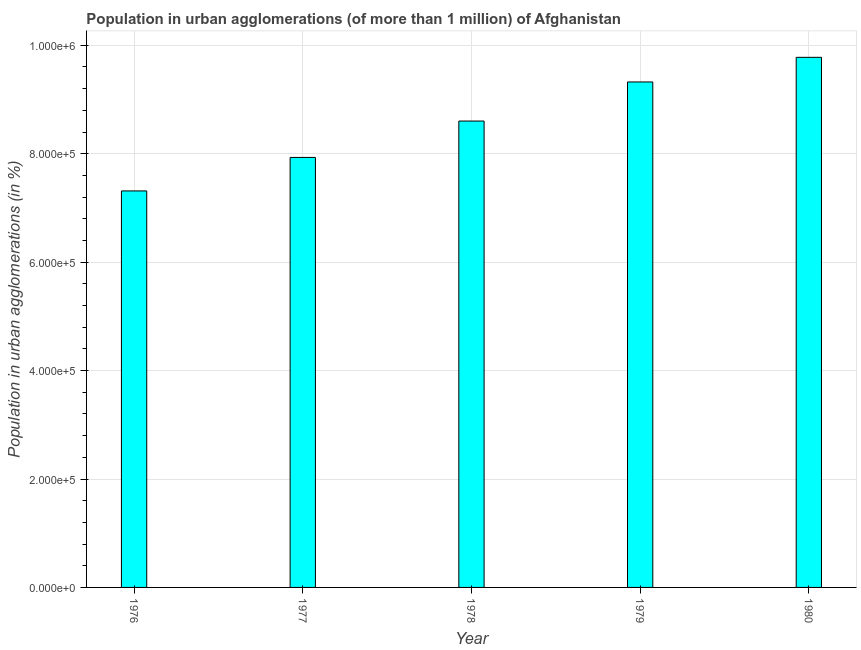Does the graph contain grids?
Give a very brief answer. Yes. What is the title of the graph?
Give a very brief answer. Population in urban agglomerations (of more than 1 million) of Afghanistan. What is the label or title of the X-axis?
Your response must be concise. Year. What is the label or title of the Y-axis?
Provide a succinct answer. Population in urban agglomerations (in %). What is the population in urban agglomerations in 1977?
Make the answer very short. 7.93e+05. Across all years, what is the maximum population in urban agglomerations?
Provide a short and direct response. 9.78e+05. Across all years, what is the minimum population in urban agglomerations?
Make the answer very short. 7.31e+05. In which year was the population in urban agglomerations maximum?
Give a very brief answer. 1980. In which year was the population in urban agglomerations minimum?
Provide a succinct answer. 1976. What is the sum of the population in urban agglomerations?
Provide a succinct answer. 4.30e+06. What is the difference between the population in urban agglomerations in 1976 and 1980?
Provide a succinct answer. -2.46e+05. What is the average population in urban agglomerations per year?
Offer a terse response. 8.59e+05. What is the median population in urban agglomerations?
Ensure brevity in your answer.  8.60e+05. Do a majority of the years between 1976 and 1978 (inclusive) have population in urban agglomerations greater than 560000 %?
Offer a very short reply. Yes. What is the ratio of the population in urban agglomerations in 1976 to that in 1979?
Your response must be concise. 0.78. Is the population in urban agglomerations in 1979 less than that in 1980?
Your answer should be very brief. Yes. What is the difference between the highest and the second highest population in urban agglomerations?
Offer a terse response. 4.54e+04. Is the sum of the population in urban agglomerations in 1976 and 1979 greater than the maximum population in urban agglomerations across all years?
Keep it short and to the point. Yes. What is the difference between the highest and the lowest population in urban agglomerations?
Your response must be concise. 2.46e+05. How many bars are there?
Ensure brevity in your answer.  5. How many years are there in the graph?
Make the answer very short. 5. Are the values on the major ticks of Y-axis written in scientific E-notation?
Your answer should be very brief. Yes. What is the Population in urban agglomerations (in %) in 1976?
Provide a succinct answer. 7.31e+05. What is the Population in urban agglomerations (in %) in 1977?
Provide a short and direct response. 7.93e+05. What is the Population in urban agglomerations (in %) of 1978?
Provide a short and direct response. 8.60e+05. What is the Population in urban agglomerations (in %) of 1979?
Make the answer very short. 9.32e+05. What is the Population in urban agglomerations (in %) in 1980?
Ensure brevity in your answer.  9.78e+05. What is the difference between the Population in urban agglomerations (in %) in 1976 and 1977?
Your response must be concise. -6.18e+04. What is the difference between the Population in urban agglomerations (in %) in 1976 and 1978?
Offer a very short reply. -1.29e+05. What is the difference between the Population in urban agglomerations (in %) in 1976 and 1979?
Offer a terse response. -2.01e+05. What is the difference between the Population in urban agglomerations (in %) in 1976 and 1980?
Your answer should be very brief. -2.46e+05. What is the difference between the Population in urban agglomerations (in %) in 1977 and 1978?
Offer a terse response. -6.71e+04. What is the difference between the Population in urban agglomerations (in %) in 1977 and 1979?
Give a very brief answer. -1.39e+05. What is the difference between the Population in urban agglomerations (in %) in 1977 and 1980?
Ensure brevity in your answer.  -1.85e+05. What is the difference between the Population in urban agglomerations (in %) in 1978 and 1979?
Make the answer very short. -7.21e+04. What is the difference between the Population in urban agglomerations (in %) in 1978 and 1980?
Your response must be concise. -1.18e+05. What is the difference between the Population in urban agglomerations (in %) in 1979 and 1980?
Keep it short and to the point. -4.54e+04. What is the ratio of the Population in urban agglomerations (in %) in 1976 to that in 1977?
Your response must be concise. 0.92. What is the ratio of the Population in urban agglomerations (in %) in 1976 to that in 1978?
Make the answer very short. 0.85. What is the ratio of the Population in urban agglomerations (in %) in 1976 to that in 1979?
Your answer should be compact. 0.78. What is the ratio of the Population in urban agglomerations (in %) in 1976 to that in 1980?
Keep it short and to the point. 0.75. What is the ratio of the Population in urban agglomerations (in %) in 1977 to that in 1978?
Provide a succinct answer. 0.92. What is the ratio of the Population in urban agglomerations (in %) in 1977 to that in 1979?
Keep it short and to the point. 0.85. What is the ratio of the Population in urban agglomerations (in %) in 1977 to that in 1980?
Your response must be concise. 0.81. What is the ratio of the Population in urban agglomerations (in %) in 1978 to that in 1979?
Provide a succinct answer. 0.92. What is the ratio of the Population in urban agglomerations (in %) in 1978 to that in 1980?
Your answer should be very brief. 0.88. What is the ratio of the Population in urban agglomerations (in %) in 1979 to that in 1980?
Provide a short and direct response. 0.95. 